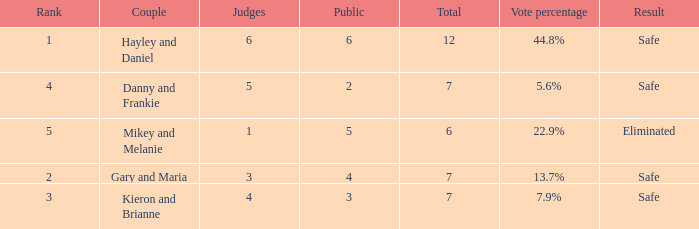What was the result for the total of 12? Safe. 